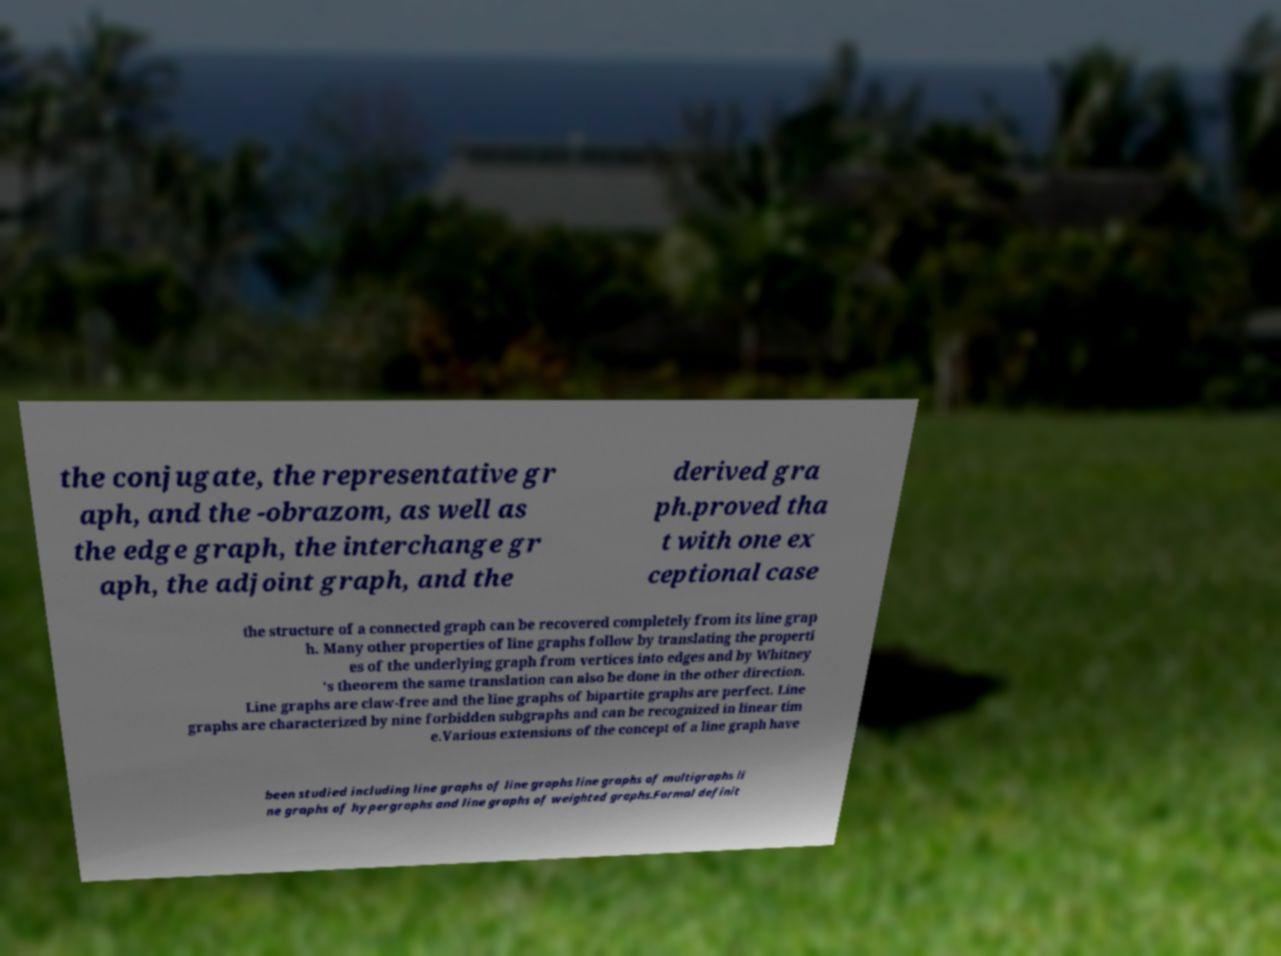I need the written content from this picture converted into text. Can you do that? the conjugate, the representative gr aph, and the -obrazom, as well as the edge graph, the interchange gr aph, the adjoint graph, and the derived gra ph.proved tha t with one ex ceptional case the structure of a connected graph can be recovered completely from its line grap h. Many other properties of line graphs follow by translating the properti es of the underlying graph from vertices into edges and by Whitney 's theorem the same translation can also be done in the other direction. Line graphs are claw-free and the line graphs of bipartite graphs are perfect. Line graphs are characterized by nine forbidden subgraphs and can be recognized in linear tim e.Various extensions of the concept of a line graph have been studied including line graphs of line graphs line graphs of multigraphs li ne graphs of hypergraphs and line graphs of weighted graphs.Formal definit 